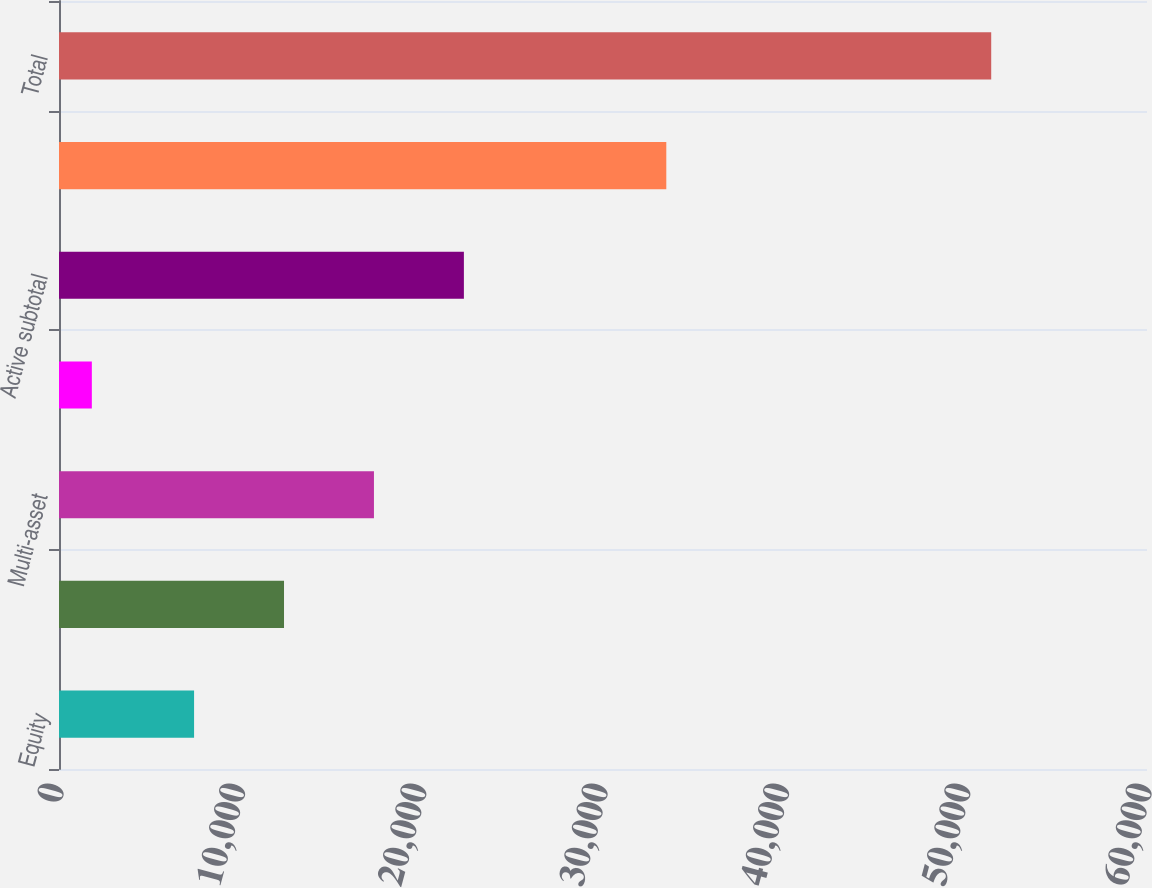Convert chart. <chart><loc_0><loc_0><loc_500><loc_500><bar_chart><fcel>Equity<fcel>Fixed income<fcel>Multi-asset<fcel>Alternatives<fcel>Active subtotal<fcel>Index subtotal<fcel>Total<nl><fcel>7449<fcel>12408.8<fcel>17368.6<fcel>1811<fcel>22328.4<fcel>33491<fcel>51409<nl></chart> 